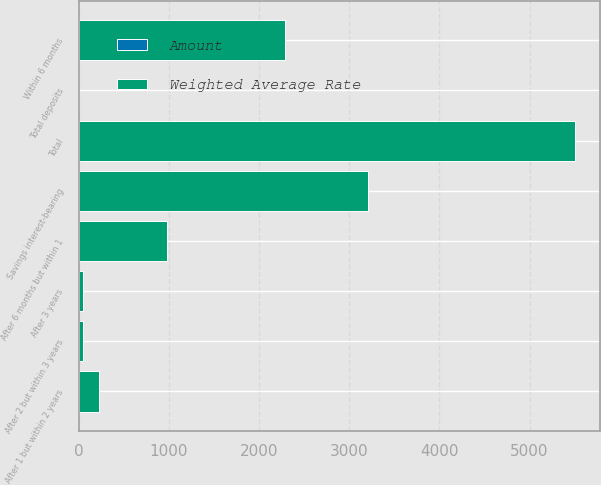<chart> <loc_0><loc_0><loc_500><loc_500><stacked_bar_chart><ecel><fcel>Savings interest-bearing<fcel>Total<fcel>Within 6 months<fcel>After 6 months but within 1<fcel>After 1 but within 2 years<fcel>After 2 but within 3 years<fcel>After 3 years<fcel>Total deposits<nl><fcel>Weighted Average Rate<fcel>3205.2<fcel>5499.6<fcel>2287.3<fcel>980.3<fcel>220.8<fcel>45.4<fcel>49.2<fcel>4.63<nl><fcel>Amount<fcel>1.39<fcel>0.81<fcel>4.49<fcel>4.63<fcel>3.65<fcel>3.14<fcel>3.88<fcel>2.25<nl></chart> 